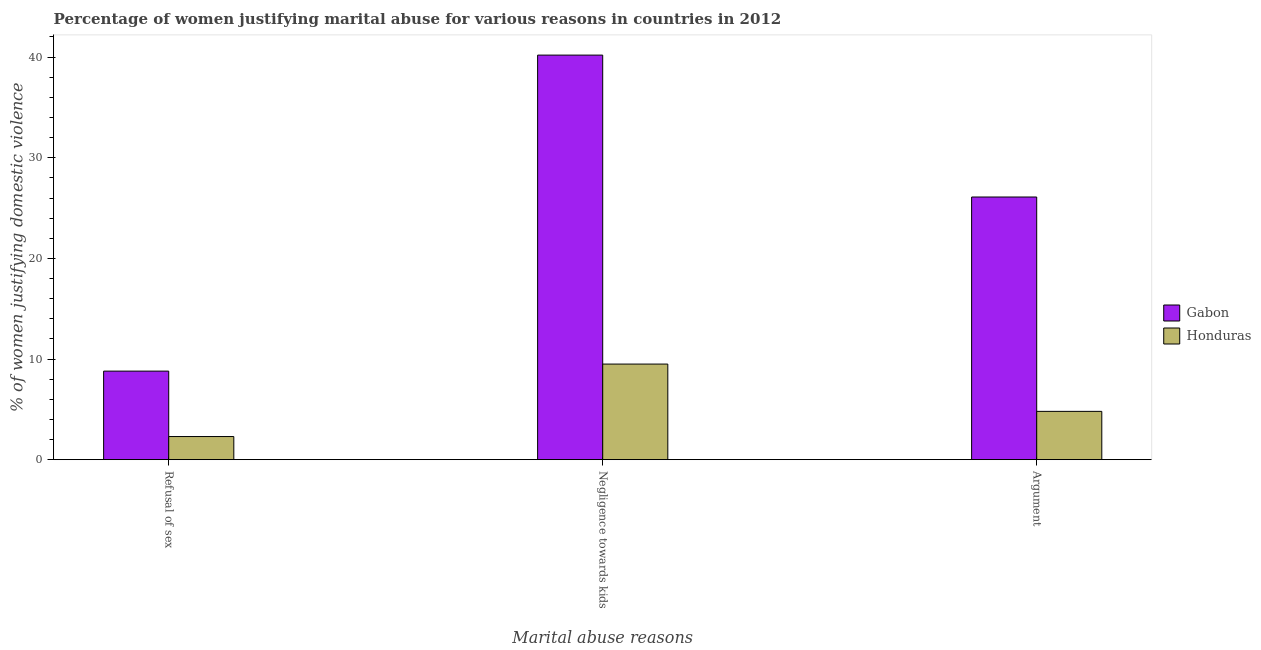Are the number of bars on each tick of the X-axis equal?
Keep it short and to the point. Yes. What is the label of the 1st group of bars from the left?
Your response must be concise. Refusal of sex. What is the percentage of women justifying domestic violence due to arguments in Gabon?
Provide a succinct answer. 26.1. Across all countries, what is the maximum percentage of women justifying domestic violence due to negligence towards kids?
Your response must be concise. 40.2. Across all countries, what is the minimum percentage of women justifying domestic violence due to refusal of sex?
Provide a short and direct response. 2.3. In which country was the percentage of women justifying domestic violence due to negligence towards kids maximum?
Your response must be concise. Gabon. In which country was the percentage of women justifying domestic violence due to negligence towards kids minimum?
Keep it short and to the point. Honduras. What is the total percentage of women justifying domestic violence due to negligence towards kids in the graph?
Your response must be concise. 49.7. What is the difference between the percentage of women justifying domestic violence due to negligence towards kids in Honduras and that in Gabon?
Provide a short and direct response. -30.7. What is the difference between the percentage of women justifying domestic violence due to refusal of sex in Honduras and the percentage of women justifying domestic violence due to arguments in Gabon?
Your response must be concise. -23.8. What is the average percentage of women justifying domestic violence due to arguments per country?
Provide a short and direct response. 15.45. What is the difference between the percentage of women justifying domestic violence due to negligence towards kids and percentage of women justifying domestic violence due to refusal of sex in Gabon?
Your answer should be very brief. 31.4. In how many countries, is the percentage of women justifying domestic violence due to negligence towards kids greater than 10 %?
Provide a succinct answer. 1. What is the ratio of the percentage of women justifying domestic violence due to arguments in Honduras to that in Gabon?
Provide a succinct answer. 0.18. What is the difference between the highest and the second highest percentage of women justifying domestic violence due to negligence towards kids?
Make the answer very short. 30.7. What is the difference between the highest and the lowest percentage of women justifying domestic violence due to refusal of sex?
Your response must be concise. 6.5. Is the sum of the percentage of women justifying domestic violence due to negligence towards kids in Honduras and Gabon greater than the maximum percentage of women justifying domestic violence due to refusal of sex across all countries?
Keep it short and to the point. Yes. What does the 1st bar from the left in Refusal of sex represents?
Provide a short and direct response. Gabon. What does the 2nd bar from the right in Negligence towards kids represents?
Offer a terse response. Gabon. Is it the case that in every country, the sum of the percentage of women justifying domestic violence due to refusal of sex and percentage of women justifying domestic violence due to negligence towards kids is greater than the percentage of women justifying domestic violence due to arguments?
Offer a very short reply. Yes. How many countries are there in the graph?
Offer a very short reply. 2. What is the difference between two consecutive major ticks on the Y-axis?
Ensure brevity in your answer.  10. Are the values on the major ticks of Y-axis written in scientific E-notation?
Your response must be concise. No. Does the graph contain any zero values?
Offer a terse response. No. Does the graph contain grids?
Offer a terse response. No. How many legend labels are there?
Offer a terse response. 2. How are the legend labels stacked?
Your response must be concise. Vertical. What is the title of the graph?
Provide a succinct answer. Percentage of women justifying marital abuse for various reasons in countries in 2012. Does "Bermuda" appear as one of the legend labels in the graph?
Provide a succinct answer. No. What is the label or title of the X-axis?
Give a very brief answer. Marital abuse reasons. What is the label or title of the Y-axis?
Provide a succinct answer. % of women justifying domestic violence. What is the % of women justifying domestic violence of Gabon in Refusal of sex?
Keep it short and to the point. 8.8. What is the % of women justifying domestic violence of Honduras in Refusal of sex?
Ensure brevity in your answer.  2.3. What is the % of women justifying domestic violence in Gabon in Negligence towards kids?
Provide a short and direct response. 40.2. What is the % of women justifying domestic violence in Honduras in Negligence towards kids?
Ensure brevity in your answer.  9.5. What is the % of women justifying domestic violence in Gabon in Argument?
Provide a short and direct response. 26.1. Across all Marital abuse reasons, what is the maximum % of women justifying domestic violence of Gabon?
Provide a succinct answer. 40.2. Across all Marital abuse reasons, what is the maximum % of women justifying domestic violence in Honduras?
Your answer should be very brief. 9.5. Across all Marital abuse reasons, what is the minimum % of women justifying domestic violence of Gabon?
Keep it short and to the point. 8.8. What is the total % of women justifying domestic violence in Gabon in the graph?
Give a very brief answer. 75.1. What is the difference between the % of women justifying domestic violence in Gabon in Refusal of sex and that in Negligence towards kids?
Your answer should be compact. -31.4. What is the difference between the % of women justifying domestic violence in Honduras in Refusal of sex and that in Negligence towards kids?
Keep it short and to the point. -7.2. What is the difference between the % of women justifying domestic violence of Gabon in Refusal of sex and that in Argument?
Your response must be concise. -17.3. What is the difference between the % of women justifying domestic violence of Gabon in Negligence towards kids and the % of women justifying domestic violence of Honduras in Argument?
Your response must be concise. 35.4. What is the average % of women justifying domestic violence in Gabon per Marital abuse reasons?
Your answer should be very brief. 25.03. What is the average % of women justifying domestic violence of Honduras per Marital abuse reasons?
Make the answer very short. 5.53. What is the difference between the % of women justifying domestic violence of Gabon and % of women justifying domestic violence of Honduras in Refusal of sex?
Provide a short and direct response. 6.5. What is the difference between the % of women justifying domestic violence in Gabon and % of women justifying domestic violence in Honduras in Negligence towards kids?
Ensure brevity in your answer.  30.7. What is the difference between the % of women justifying domestic violence in Gabon and % of women justifying domestic violence in Honduras in Argument?
Provide a short and direct response. 21.3. What is the ratio of the % of women justifying domestic violence of Gabon in Refusal of sex to that in Negligence towards kids?
Keep it short and to the point. 0.22. What is the ratio of the % of women justifying domestic violence of Honduras in Refusal of sex to that in Negligence towards kids?
Your answer should be compact. 0.24. What is the ratio of the % of women justifying domestic violence in Gabon in Refusal of sex to that in Argument?
Offer a terse response. 0.34. What is the ratio of the % of women justifying domestic violence of Honduras in Refusal of sex to that in Argument?
Keep it short and to the point. 0.48. What is the ratio of the % of women justifying domestic violence in Gabon in Negligence towards kids to that in Argument?
Offer a terse response. 1.54. What is the ratio of the % of women justifying domestic violence in Honduras in Negligence towards kids to that in Argument?
Give a very brief answer. 1.98. What is the difference between the highest and the second highest % of women justifying domestic violence in Gabon?
Keep it short and to the point. 14.1. What is the difference between the highest and the lowest % of women justifying domestic violence of Gabon?
Your answer should be very brief. 31.4. What is the difference between the highest and the lowest % of women justifying domestic violence in Honduras?
Ensure brevity in your answer.  7.2. 